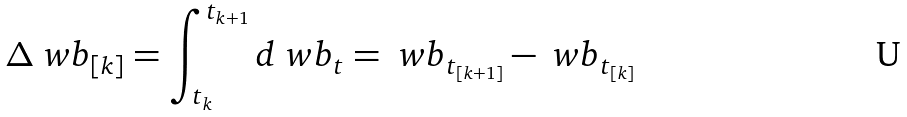<formula> <loc_0><loc_0><loc_500><loc_500>\Delta \ w b _ { [ k ] } = \int _ { t _ { k } } ^ { t _ { k + 1 } } d \ w b _ { t } = \ w b _ { t _ { [ k + 1 ] } } - \ w b _ { t _ { [ k ] } }</formula> 